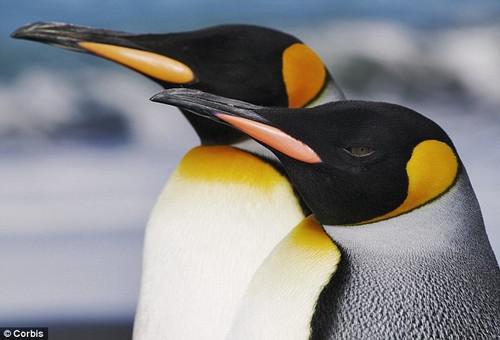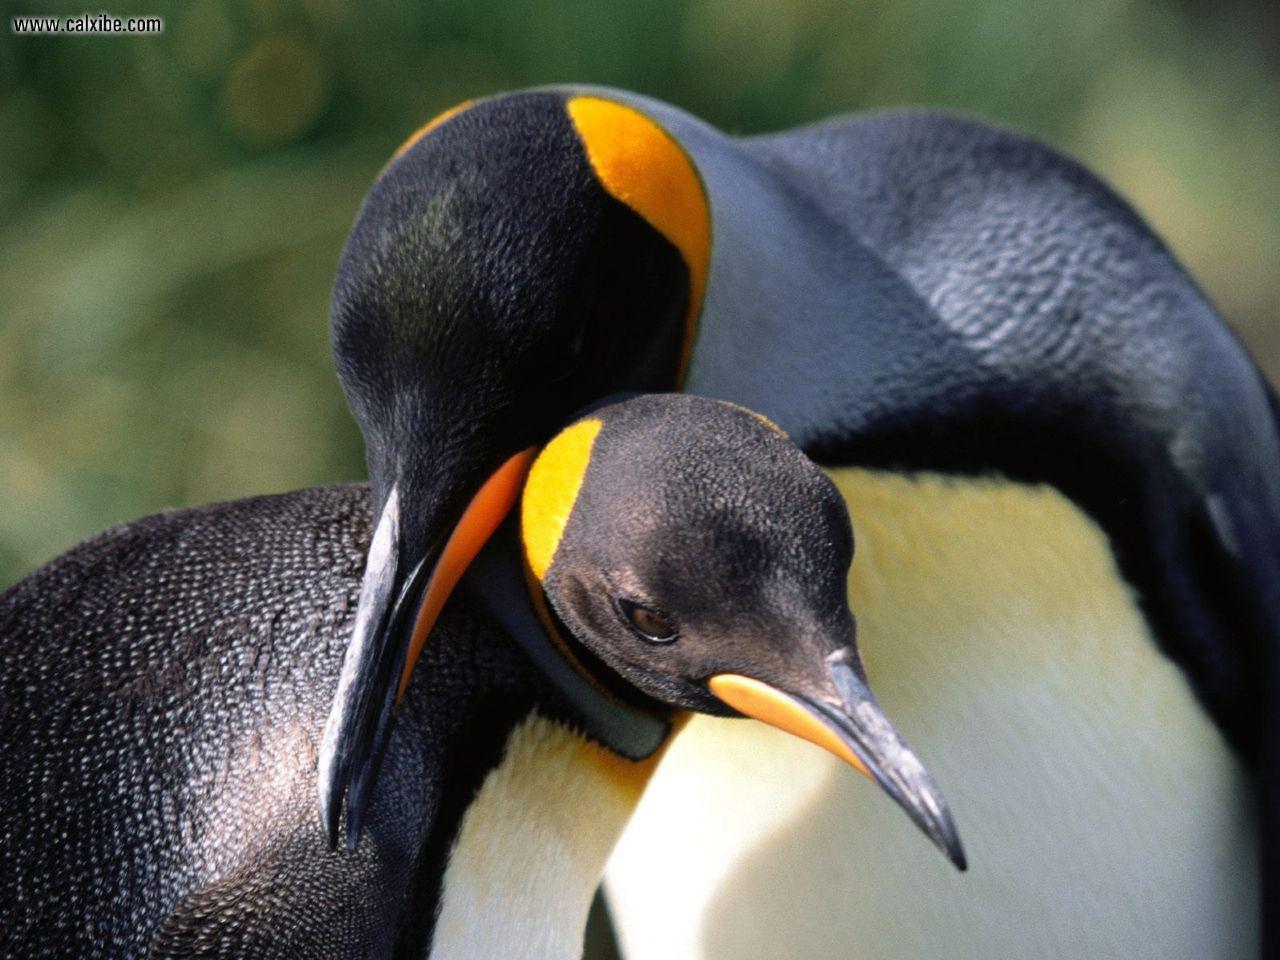The first image is the image on the left, the second image is the image on the right. Analyze the images presented: Is the assertion "One penguin is touching another penguins beak with its beak." valid? Answer yes or no. No. The first image is the image on the left, the second image is the image on the right. Analyze the images presented: Is the assertion "There are two penguins facing the same direction in the left image." valid? Answer yes or no. Yes. 